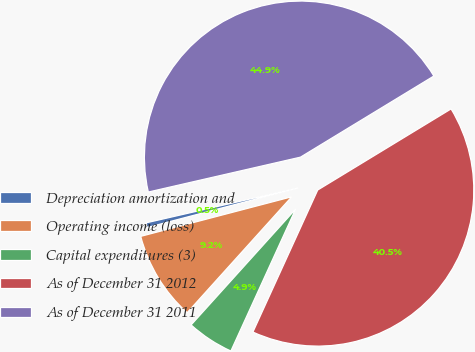Convert chart to OTSL. <chart><loc_0><loc_0><loc_500><loc_500><pie_chart><fcel>Depreciation amortization and<fcel>Operating income (loss)<fcel>Capital expenditures (3)<fcel>As of December 31 2012<fcel>As of December 31 2011<nl><fcel>0.49%<fcel>9.24%<fcel>4.87%<fcel>40.51%<fcel>44.89%<nl></chart> 